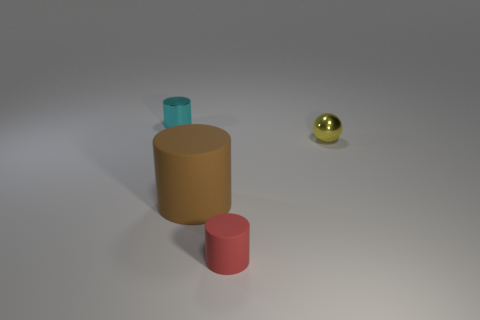What number of small cyan cylinders are the same material as the brown cylinder?
Keep it short and to the point. 0. What number of rubber objects are either brown things or big green things?
Your answer should be very brief. 1. There is a cyan thing that is the same size as the yellow object; what is it made of?
Offer a very short reply. Metal. Is there a brown ball made of the same material as the small red thing?
Give a very brief answer. No. What is the shape of the small metal object that is right of the metallic thing behind the tiny shiny thing right of the cyan thing?
Your response must be concise. Sphere. Do the brown cylinder and the metallic thing that is right of the cyan metal thing have the same size?
Provide a short and direct response. No. There is a thing that is right of the metal cylinder and to the left of the tiny rubber cylinder; what shape is it?
Provide a short and direct response. Cylinder. How many large objects are yellow things or red cylinders?
Your response must be concise. 0. Are there an equal number of matte objects that are behind the tiny red object and brown matte cylinders in front of the brown cylinder?
Ensure brevity in your answer.  No. What number of other objects are there of the same color as the big cylinder?
Offer a terse response. 0. 